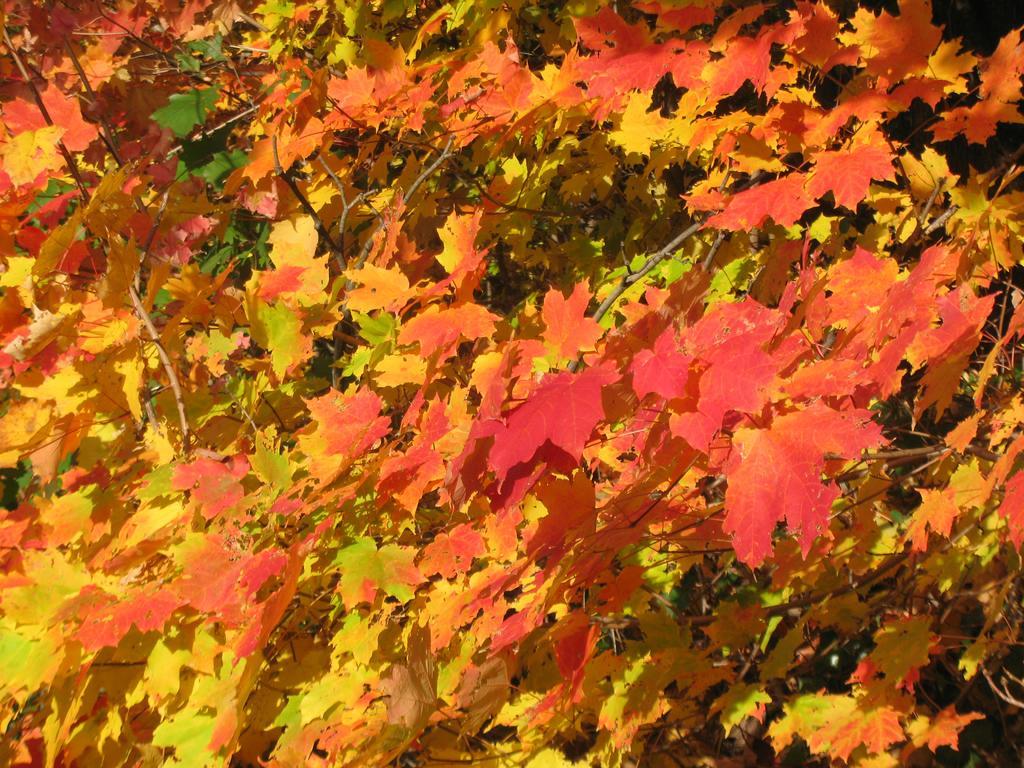How would you summarize this image in a sentence or two? In this image we can see many maple leaves. 